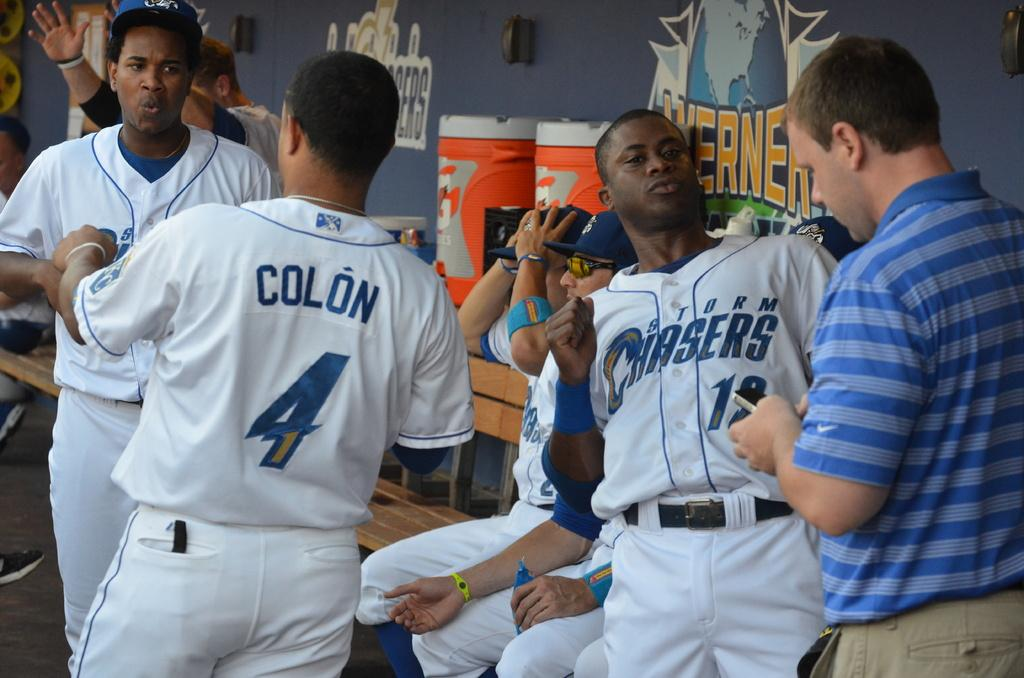<image>
Describe the image concisely. Several players for the Storm Chasers are in the dugout. 